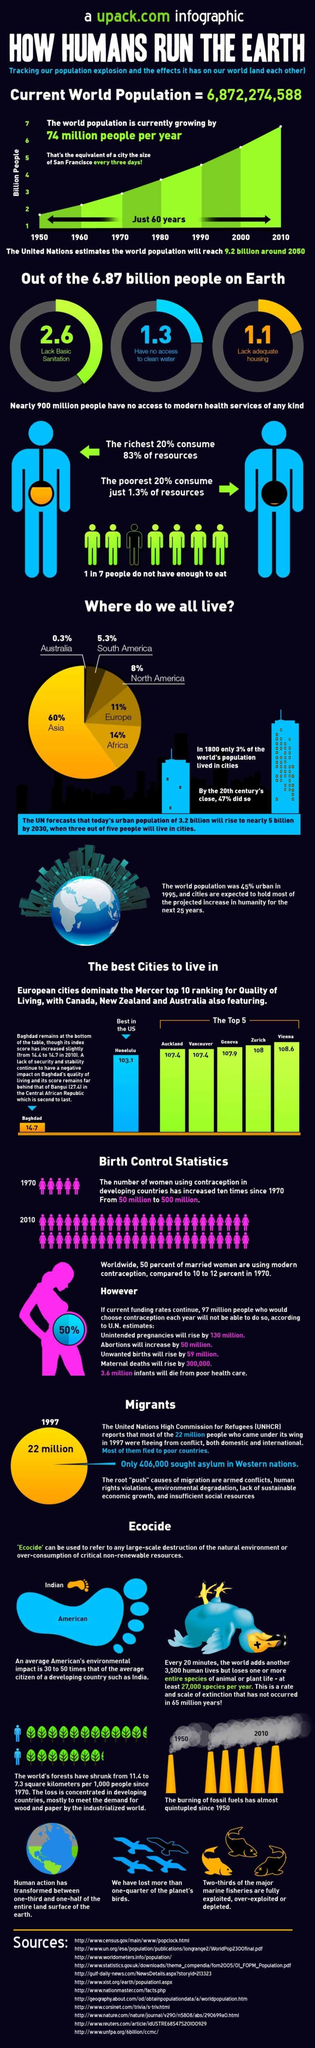What percent of world's population live in Europe?
Answer the question with a short phrase. 11% What percent of world's population live in Africa? 14% Which is the most densely populated continent in the world? Asia What population (in billions) in the world lack basic sanitation? 2.6 What population (in billions) in the world have no access to clean water? 1.3 Which city in the U.S. has ranked top for the quality of living? Honolulu 